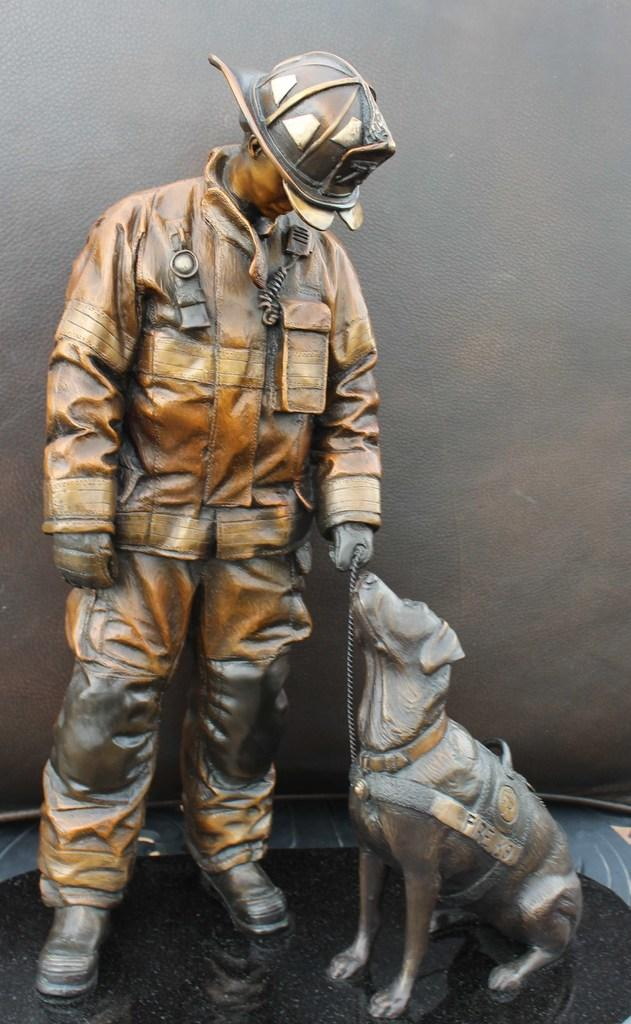What is the main subject of the image? The main subject of the image is a sculpture of a boy and a dog. What is the boy doing in the sculpture? The boy is holding a leash on the dog. What is the boy's facial expression or direction of gaze? The boy is looking towards the dog. What type of ant can be seen crawling on the boy's skin in the image? There is no ant present on the boy's skin in the image; it is a sculpture of a boy and a dog. What kind of patch is visible on the dog's fur in the image? There is no patch visible on the dog's fur in the image; it is a sculpture of a boy and a dog. 